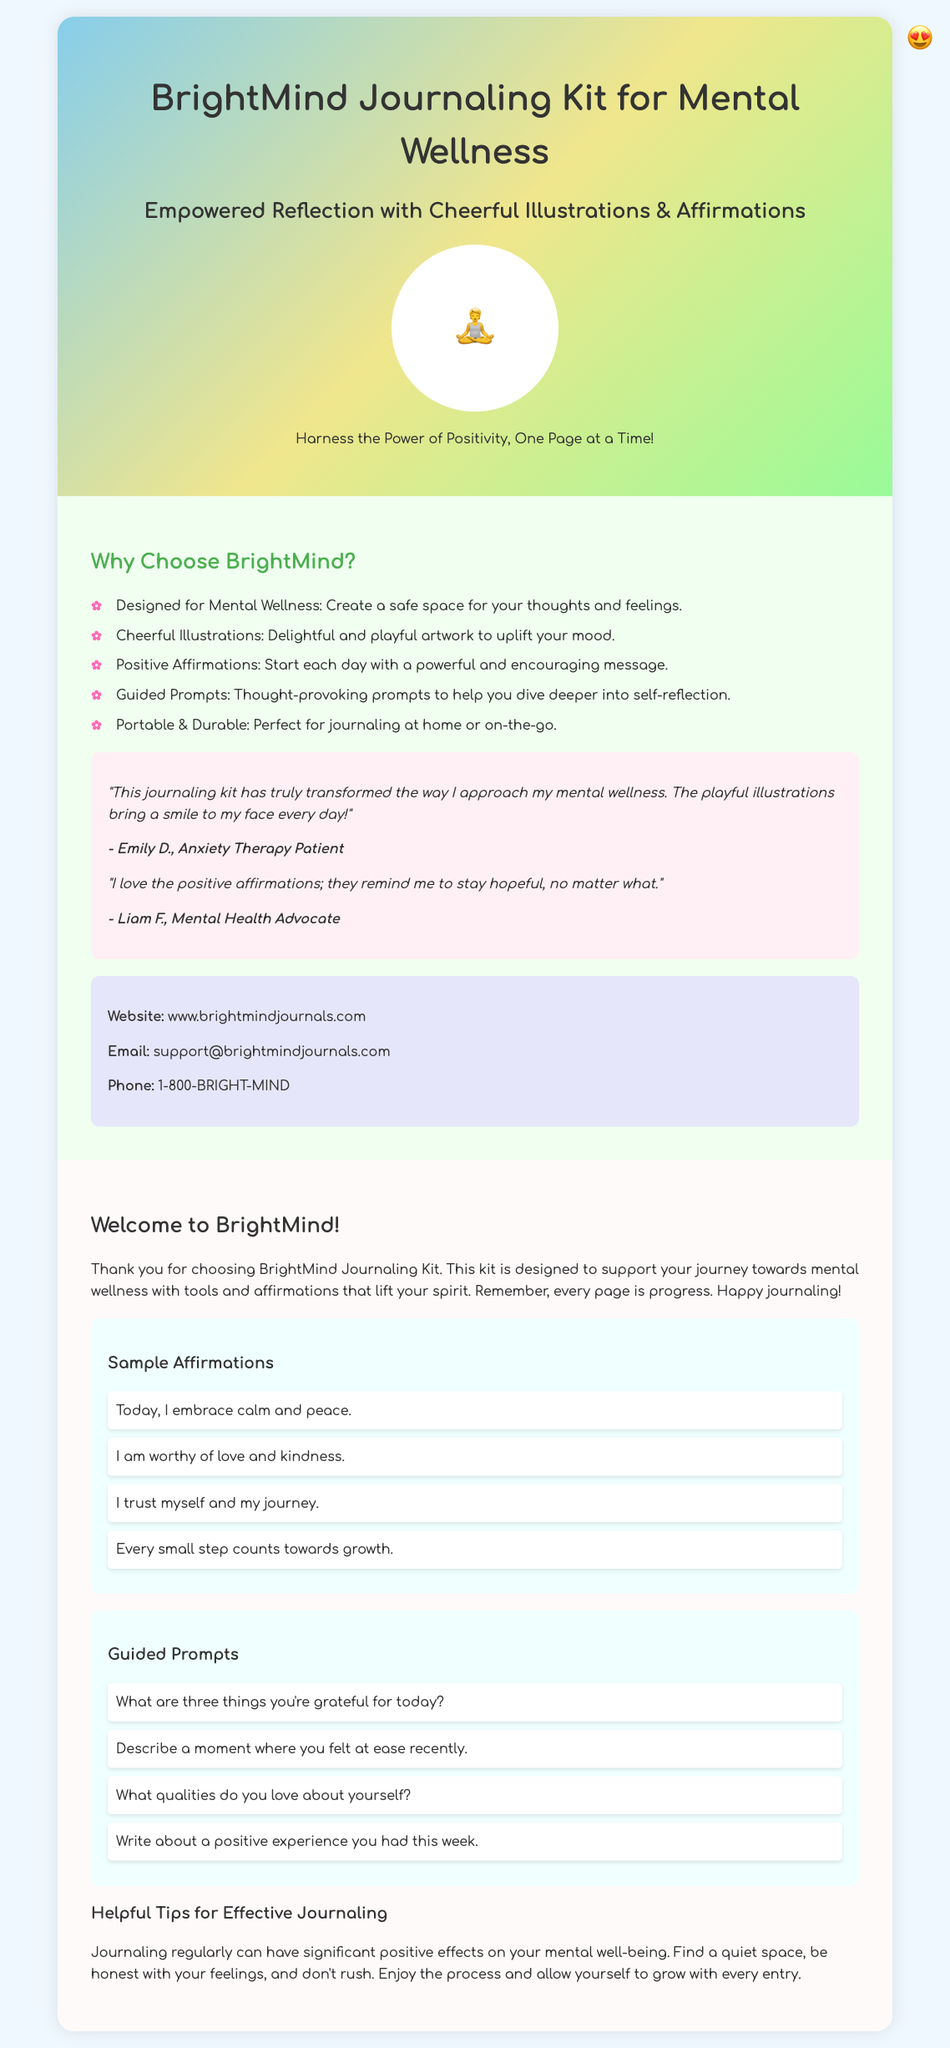What is the name of the journaling kit? The title prominently displayed on the front cover identifies the product as "BrightMind Journaling Kit for Mental Wellness."
Answer: BrightMind Journaling Kit for Mental Wellness How many guided prompts are included? The document lists four specific prompts under the "Guided Prompts" section.
Answer: Four What color is the background of the back cover? The back cover is described to have a light green color (#F0FFF0).
Answer: Light green Who is a testimonial from? Two testimonials are provided, one from Emily D. and another from Liam F.
Answer: Emily D What is a sample affirmation included? The document provides several affirmations; one of them is "Today, I embrace calm and peace."
Answer: Today, I embrace calm and peace What is the contact email for support? The contact information provided includes the email support@brightmindjournals.com.
Answer: support@brightmindjournals.com What is the aesthetic feature of the illustrations? The document mentions that the illustrations are "delightful and playful," contributing to the overall cheerful theme.
Answer: Delightful and playful What is the purpose of the BrightMind Journaling Kit? The document states it is designed to support mental wellness.
Answer: Support mental wellness 